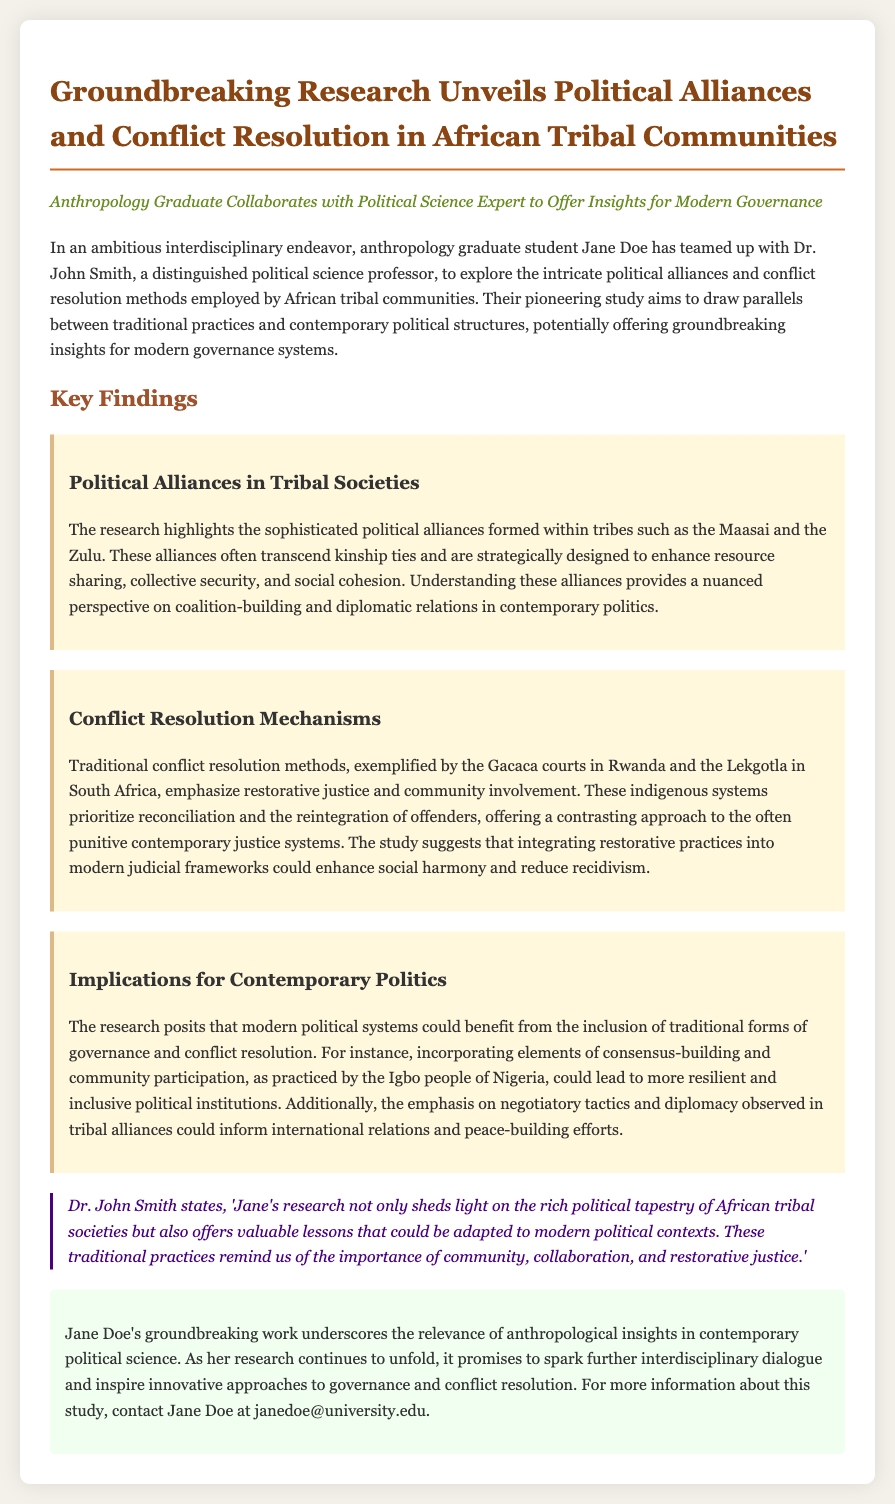What is the name of the anthropology graduate student? The document states that the anthropology graduate student is named Jane Doe.
Answer: Jane Doe Who is the political science professor collaborating with Jane Doe? According to the press release, the collaborating political science professor is Dr. John Smith.
Answer: Dr. John Smith What are the names of the tribal communities studied in the research? The research highlights political alliances in tribes such as the Maasai and the Zulu.
Answer: Maasai and Zulu What conflict resolution mechanism is exemplified in the document? The document mentions Gacaca courts in Rwanda and Lekgotla in South Africa as examples of conflict resolution mechanisms.
Answer: Gacaca courts and Lekgotla What is a key aspect of traditional conflict resolution highlighted in the research? The research emphasizes restorative justice and community involvement in traditional conflict resolution methods.
Answer: Restorative justice and community involvement What potential benefit does modern political systems derive from traditional governance? The study suggests that modern political systems could benefit from the inclusion of traditional forms of governance and conflict resolution.
Answer: Inclusion of traditional forms What lesson does Dr. John Smith believe can be adapted to modern political contexts? Dr. John Smith states that traditional practices remind us of the importance of community and collaboration.
Answer: Importance of community and collaboration What is the primary goal of Jane Doe’s research? The primary goal of Jane Doe's research is to explore political alliances and conflict resolution methods in African tribal communities.
Answer: Explore political alliances and conflict resolution methods What type of justice is emphasized in the indigenous systems discussed? The document notes that traditional conflict resolution methods prioritize reconciliation, indicating a focus on restorative justice.
Answer: Restorative justice 